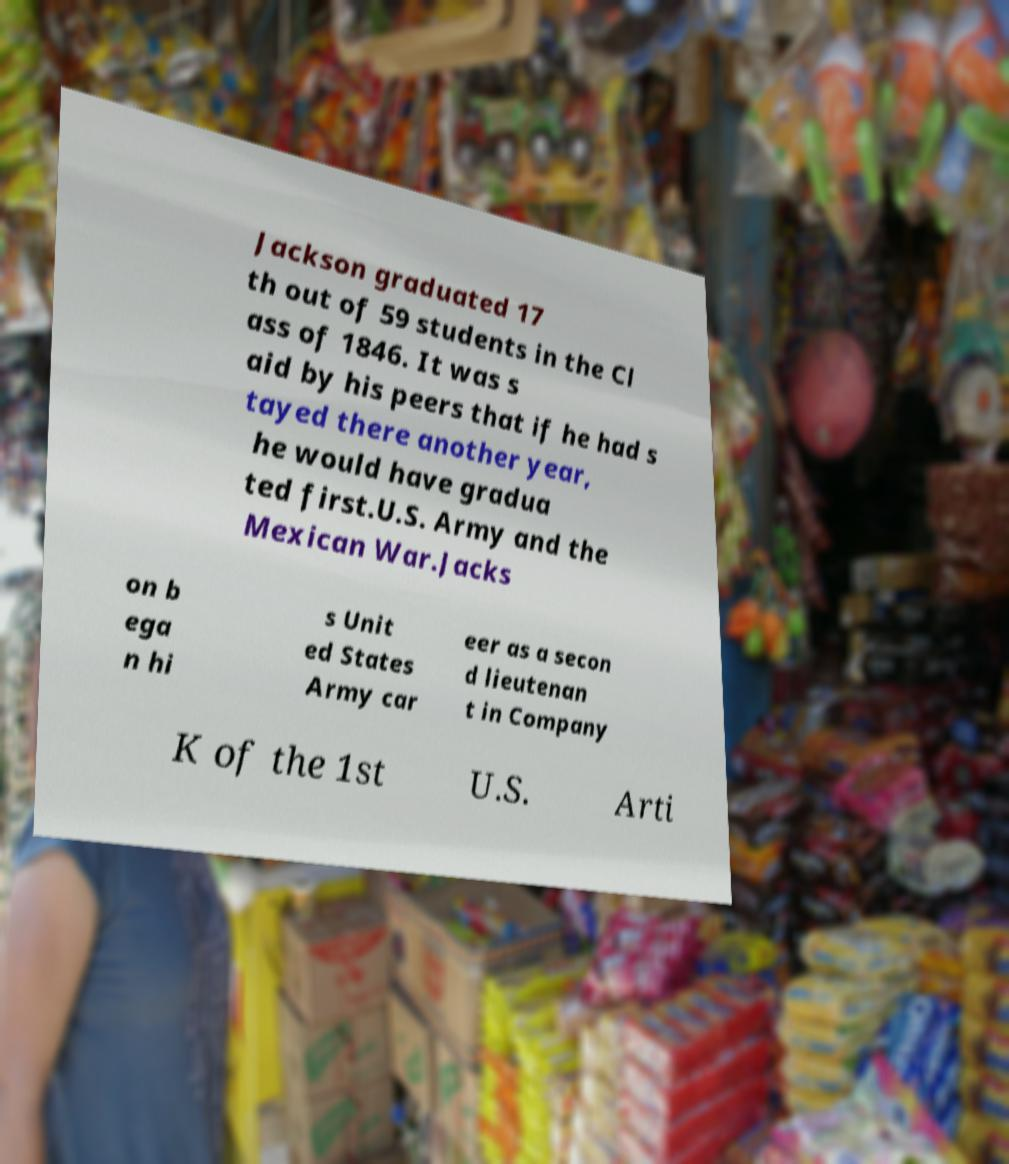Could you assist in decoding the text presented in this image and type it out clearly? Jackson graduated 17 th out of 59 students in the Cl ass of 1846. It was s aid by his peers that if he had s tayed there another year, he would have gradua ted first.U.S. Army and the Mexican War.Jacks on b ega n hi s Unit ed States Army car eer as a secon d lieutenan t in Company K of the 1st U.S. Arti 